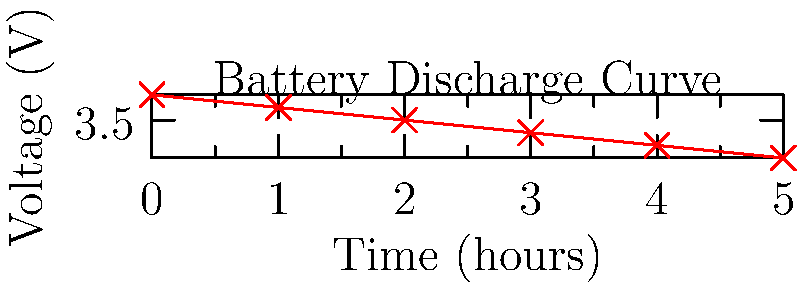A wearable device for monitoring dancers' vital signs uses a lithium-ion battery with the discharge curve shown above. If the minimum operating voltage for the device is 3.3V, what is the maximum runtime in hours that can be achieved without recharging, assuming a linear discharge rate? To solve this problem, we need to follow these steps:

1. Identify the starting voltage: From the graph, we can see that the initial voltage is 3.7V.

2. Identify the cutoff voltage: The question states that the minimum operating voltage is 3.3V.

3. Calculate the voltage drop: $\Delta V = 3.7V - 3.3V = 0.4V$

4. Determine the discharge rate: We can see from the graph that the voltage drops linearly. To calculate the rate, we can use two points:
   At t = 0h, V = 3.7V
   At t = 5h, V = 3.2V
   
   Discharge rate = $\frac{3.7V - 3.2V}{5h} = \frac{0.5V}{5h} = 0.1 V/h$

5. Calculate the time to reach cutoff voltage:
   $Time = \frac{Voltage drop}{Discharge rate} = \frac{0.4V}{0.1 V/h} = 4 hours$

Therefore, the maximum runtime that can be achieved without recharging is 4 hours.
Answer: 4 hours 